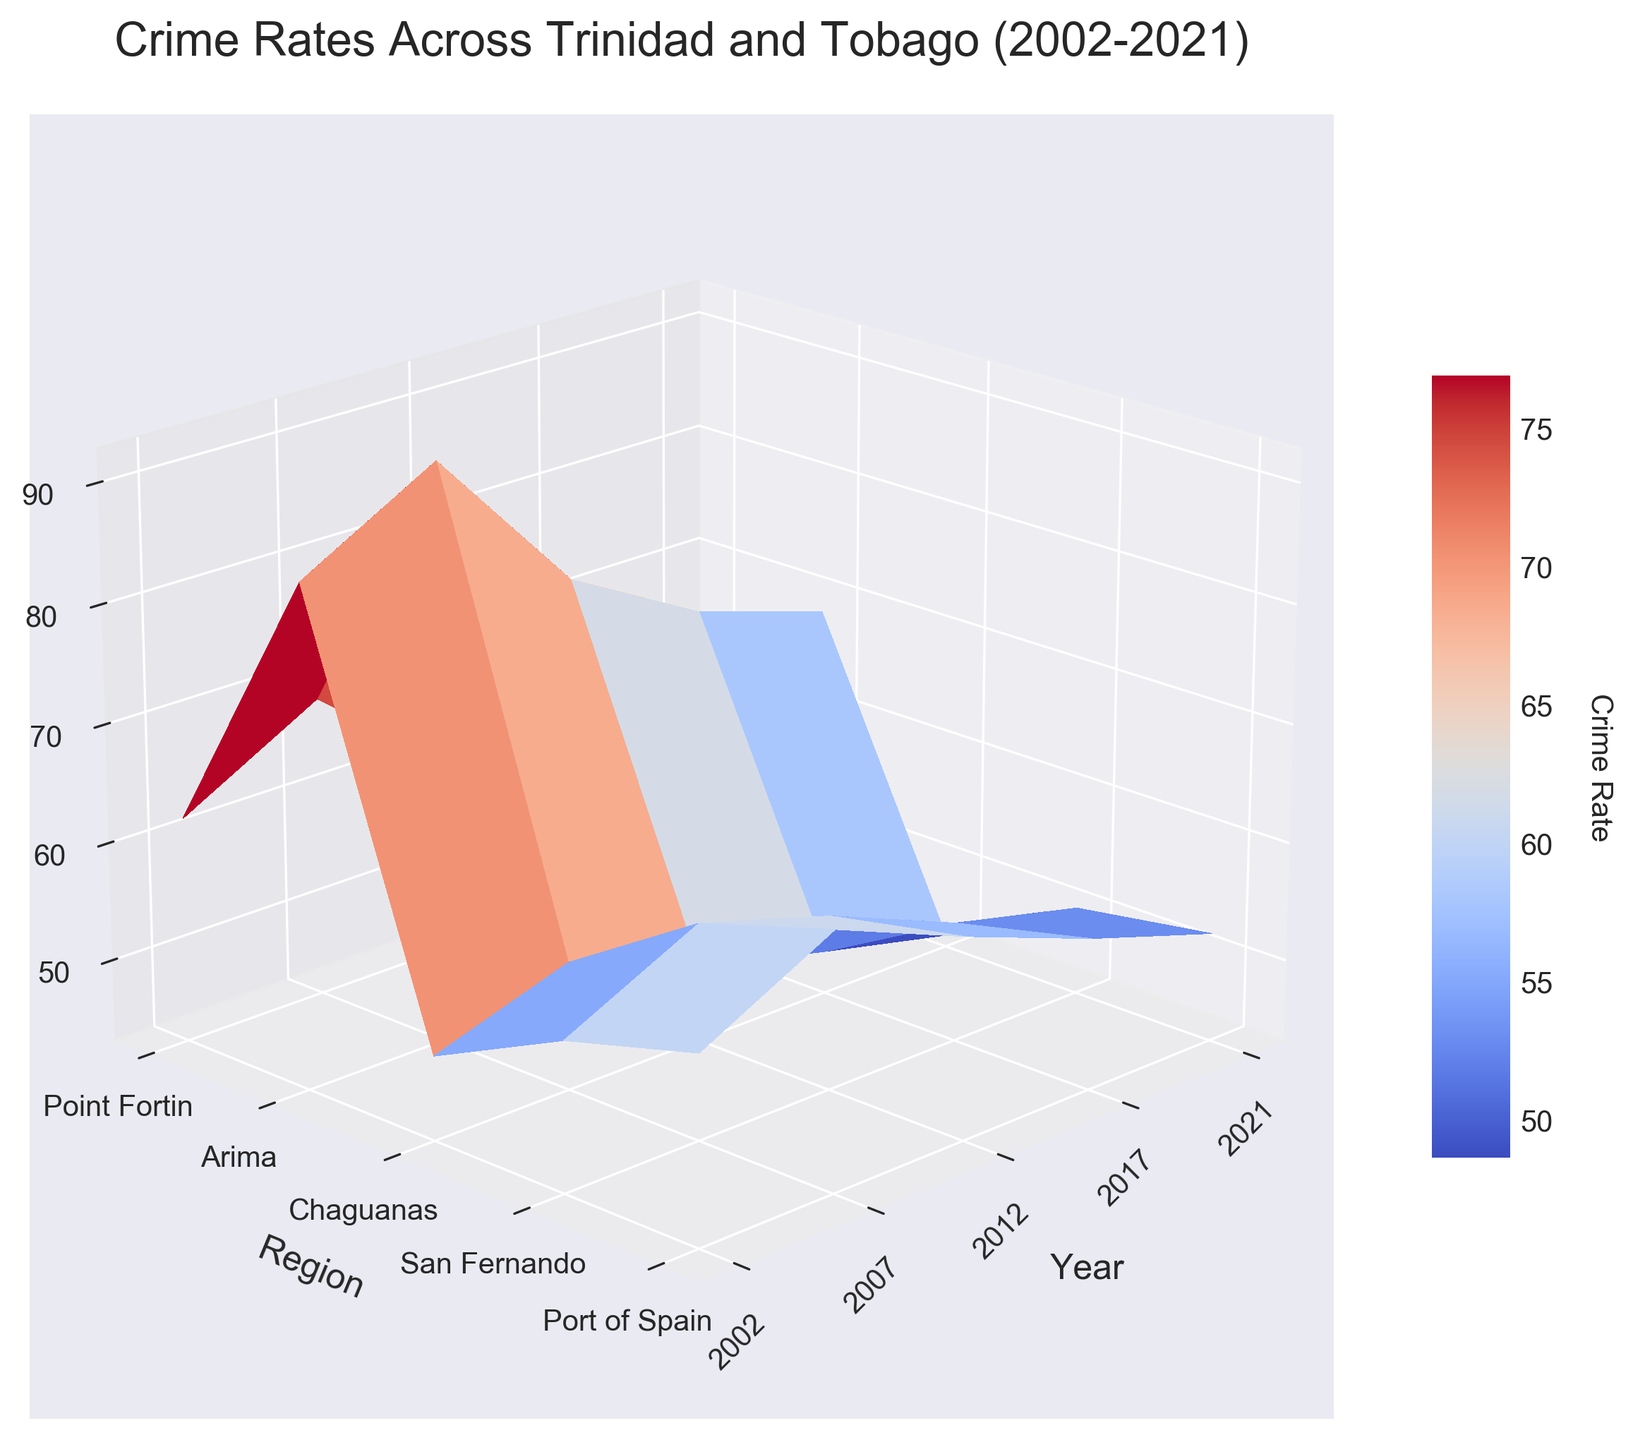What is the title of the figure? The title is typically large text located above the 3D surface plot. In this case, it is written as 'Crime Rates Across Trinidad and Tobago (2002-2021)'.
Answer: Crime Rates Across Trinidad and Tobago (2002-2021) What does the z-axis represent? The z-axis is labeled on the figure and usually indicates the dimension that varies with height. In this plot, it is labeled 'Crime Rate'.
Answer: Crime Rate Which region had the highest crime rate in 2007? By looking at the 3D peaks corresponding to the year 2007, we can identify the highest point. In the year 2007's slice, 'Port of Spain' shows the highest peak.
Answer: Port of Spain What year has the highest overall crime rates? By examining the highest points on the surface plot for each year, it becomes clear that the year 2007 has taller peaks compared to other years.
Answer: 2007 How did the crime rate change in Port of Spain from 2002 to 2021? Observe the segment of the surface plot associated with 'Port of Spain' and compare the heights of the points from 2002 to 2021. The crime rate decreased from 85.3 in 2002 to 68.9 in 2021.
Answer: Decreased Which region experienced the most consistent decrease in crime rates over the years? By examining the surface plot trajectories across all years for each region, 'Point Fortin' shows a steady decrease in crime rates.
Answer: Point Fortin Is there a year where crime rates in all regions decreased compared to the previous recorded year? Examine dips in the 3D surface for all regions for every year compared to the year before it. Comparing 2017 to 2012, all regions have lower crime rates in 2017.
Answer: 2017 What is the color bar used for in the plot? The color bar, which is usually positioned beside the plot, indicates the range of crime rates, with different colors representing different rates.
Answer: Crime Rate Identify the region with the lowest crime rate in 2021 and how it compares to its rate in 2002. By finding the lowest point in the 2021 slice and checking the corresponding value against 2002, 'Point Fortin' is lowest with 44.1 in 2021 compared to 50.2 in 2002.
Answer: Point Fortin, decreased from 50.2 to 44.1 Which year had the steepest decline in crime rates compared to the previous recorded year in San Fernando? Check the difference in crime rates for 'San Fernando' across recorded years and identify the biggest drop. From 2007 to 2012, it declined the most from 68.5 to 59.3.
Answer: 2012 